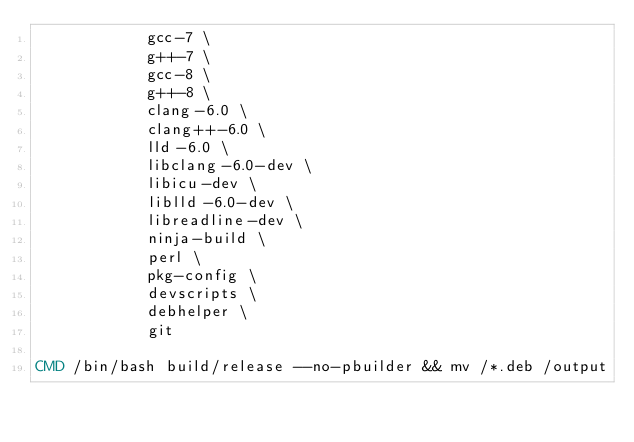Convert code to text. <code><loc_0><loc_0><loc_500><loc_500><_Dockerfile_>            gcc-7 \
            g++-7 \
            gcc-8 \
            g++-8 \
            clang-6.0 \
            clang++-6.0 \
            lld-6.0 \
            libclang-6.0-dev \
            libicu-dev \
            liblld-6.0-dev \
            libreadline-dev \
            ninja-build \
            perl \
            pkg-config \
            devscripts \
            debhelper \
            git

CMD /bin/bash build/release --no-pbuilder && mv /*.deb /output
</code> 